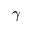<formula> <loc_0><loc_0><loc_500><loc_500>\gamma</formula> 